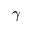<formula> <loc_0><loc_0><loc_500><loc_500>\gamma</formula> 